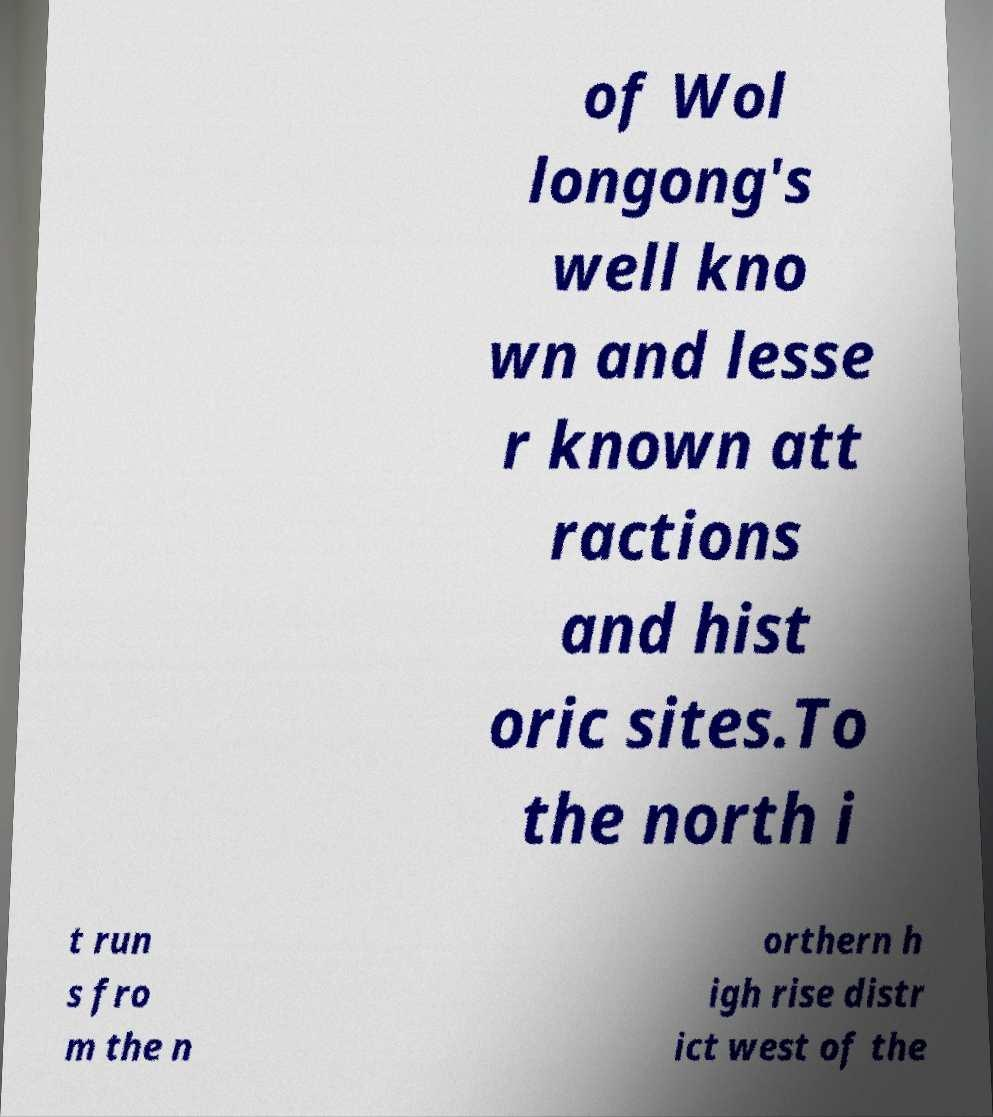Can you accurately transcribe the text from the provided image for me? of Wol longong's well kno wn and lesse r known att ractions and hist oric sites.To the north i t run s fro m the n orthern h igh rise distr ict west of the 